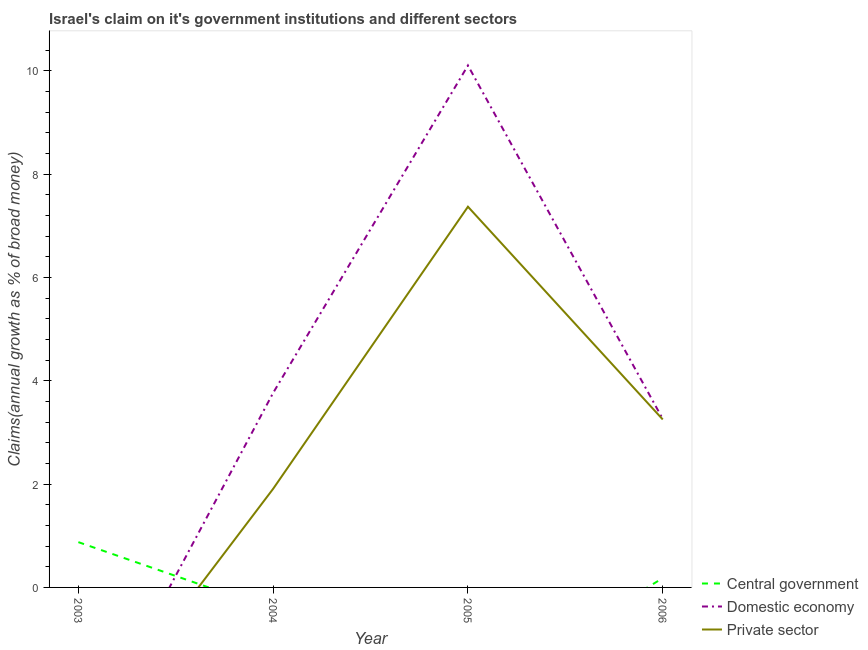How many different coloured lines are there?
Give a very brief answer. 3. What is the percentage of claim on the domestic economy in 2006?
Provide a succinct answer. 3.26. Across all years, what is the maximum percentage of claim on the private sector?
Offer a terse response. 7.37. In which year was the percentage of claim on the domestic economy maximum?
Offer a very short reply. 2005. What is the total percentage of claim on the central government in the graph?
Provide a short and direct response. 1.06. What is the difference between the percentage of claim on the domestic economy in 2004 and that in 2006?
Make the answer very short. 0.51. What is the difference between the percentage of claim on the private sector in 2006 and the percentage of claim on the domestic economy in 2005?
Your answer should be compact. -6.85. What is the average percentage of claim on the private sector per year?
Make the answer very short. 3.13. In the year 2006, what is the difference between the percentage of claim on the central government and percentage of claim on the private sector?
Make the answer very short. -3.07. In how many years, is the percentage of claim on the central government greater than 4.8 %?
Provide a succinct answer. 0. What is the ratio of the percentage of claim on the central government in 2003 to that in 2006?
Your answer should be compact. 4.87. Is the percentage of claim on the central government in 2003 less than that in 2006?
Offer a terse response. No. What is the difference between the highest and the second highest percentage of claim on the domestic economy?
Your answer should be compact. 6.34. What is the difference between the highest and the lowest percentage of claim on the domestic economy?
Give a very brief answer. 10.1. In how many years, is the percentage of claim on the private sector greater than the average percentage of claim on the private sector taken over all years?
Your answer should be compact. 2. Is the sum of the percentage of claim on the private sector in 2004 and 2005 greater than the maximum percentage of claim on the domestic economy across all years?
Provide a short and direct response. No. Is it the case that in every year, the sum of the percentage of claim on the central government and percentage of claim on the domestic economy is greater than the percentage of claim on the private sector?
Make the answer very short. Yes. Is the percentage of claim on the central government strictly greater than the percentage of claim on the private sector over the years?
Your response must be concise. No. How many years are there in the graph?
Provide a short and direct response. 4. What is the difference between two consecutive major ticks on the Y-axis?
Keep it short and to the point. 2. Are the values on the major ticks of Y-axis written in scientific E-notation?
Give a very brief answer. No. Does the graph contain any zero values?
Provide a succinct answer. Yes. Does the graph contain grids?
Your response must be concise. No. How are the legend labels stacked?
Offer a very short reply. Vertical. What is the title of the graph?
Your answer should be compact. Israel's claim on it's government institutions and different sectors. What is the label or title of the Y-axis?
Keep it short and to the point. Claims(annual growth as % of broad money). What is the Claims(annual growth as % of broad money) of Central government in 2003?
Make the answer very short. 0.88. What is the Claims(annual growth as % of broad money) in Private sector in 2003?
Your answer should be compact. 0. What is the Claims(annual growth as % of broad money) of Domestic economy in 2004?
Offer a very short reply. 3.77. What is the Claims(annual growth as % of broad money) in Private sector in 2004?
Provide a succinct answer. 1.91. What is the Claims(annual growth as % of broad money) of Central government in 2005?
Provide a short and direct response. 0. What is the Claims(annual growth as % of broad money) of Domestic economy in 2005?
Your answer should be very brief. 10.1. What is the Claims(annual growth as % of broad money) in Private sector in 2005?
Ensure brevity in your answer.  7.37. What is the Claims(annual growth as % of broad money) of Central government in 2006?
Provide a short and direct response. 0.18. What is the Claims(annual growth as % of broad money) of Domestic economy in 2006?
Make the answer very short. 3.26. What is the Claims(annual growth as % of broad money) in Private sector in 2006?
Give a very brief answer. 3.25. Across all years, what is the maximum Claims(annual growth as % of broad money) in Central government?
Your answer should be very brief. 0.88. Across all years, what is the maximum Claims(annual growth as % of broad money) of Domestic economy?
Ensure brevity in your answer.  10.1. Across all years, what is the maximum Claims(annual growth as % of broad money) of Private sector?
Make the answer very short. 7.37. Across all years, what is the minimum Claims(annual growth as % of broad money) of Central government?
Ensure brevity in your answer.  0. Across all years, what is the minimum Claims(annual growth as % of broad money) of Domestic economy?
Offer a terse response. 0. What is the total Claims(annual growth as % of broad money) in Central government in the graph?
Provide a succinct answer. 1.06. What is the total Claims(annual growth as % of broad money) of Domestic economy in the graph?
Provide a short and direct response. 17.13. What is the total Claims(annual growth as % of broad money) of Private sector in the graph?
Offer a very short reply. 12.53. What is the difference between the Claims(annual growth as % of broad money) in Central government in 2003 and that in 2006?
Your answer should be very brief. 0.7. What is the difference between the Claims(annual growth as % of broad money) in Domestic economy in 2004 and that in 2005?
Provide a succinct answer. -6.34. What is the difference between the Claims(annual growth as % of broad money) of Private sector in 2004 and that in 2005?
Provide a short and direct response. -5.46. What is the difference between the Claims(annual growth as % of broad money) of Domestic economy in 2004 and that in 2006?
Offer a terse response. 0.51. What is the difference between the Claims(annual growth as % of broad money) of Private sector in 2004 and that in 2006?
Provide a succinct answer. -1.34. What is the difference between the Claims(annual growth as % of broad money) of Domestic economy in 2005 and that in 2006?
Make the answer very short. 6.84. What is the difference between the Claims(annual growth as % of broad money) in Private sector in 2005 and that in 2006?
Make the answer very short. 4.12. What is the difference between the Claims(annual growth as % of broad money) of Central government in 2003 and the Claims(annual growth as % of broad money) of Domestic economy in 2004?
Your response must be concise. -2.89. What is the difference between the Claims(annual growth as % of broad money) in Central government in 2003 and the Claims(annual growth as % of broad money) in Private sector in 2004?
Your answer should be compact. -1.03. What is the difference between the Claims(annual growth as % of broad money) in Central government in 2003 and the Claims(annual growth as % of broad money) in Domestic economy in 2005?
Offer a terse response. -9.23. What is the difference between the Claims(annual growth as % of broad money) in Central government in 2003 and the Claims(annual growth as % of broad money) in Private sector in 2005?
Give a very brief answer. -6.49. What is the difference between the Claims(annual growth as % of broad money) in Central government in 2003 and the Claims(annual growth as % of broad money) in Domestic economy in 2006?
Your response must be concise. -2.38. What is the difference between the Claims(annual growth as % of broad money) in Central government in 2003 and the Claims(annual growth as % of broad money) in Private sector in 2006?
Your response must be concise. -2.37. What is the difference between the Claims(annual growth as % of broad money) of Domestic economy in 2004 and the Claims(annual growth as % of broad money) of Private sector in 2005?
Your answer should be very brief. -3.6. What is the difference between the Claims(annual growth as % of broad money) in Domestic economy in 2004 and the Claims(annual growth as % of broad money) in Private sector in 2006?
Provide a succinct answer. 0.51. What is the difference between the Claims(annual growth as % of broad money) in Domestic economy in 2005 and the Claims(annual growth as % of broad money) in Private sector in 2006?
Make the answer very short. 6.85. What is the average Claims(annual growth as % of broad money) of Central government per year?
Offer a terse response. 0.26. What is the average Claims(annual growth as % of broad money) in Domestic economy per year?
Provide a succinct answer. 4.28. What is the average Claims(annual growth as % of broad money) of Private sector per year?
Your response must be concise. 3.13. In the year 2004, what is the difference between the Claims(annual growth as % of broad money) of Domestic economy and Claims(annual growth as % of broad money) of Private sector?
Your answer should be compact. 1.86. In the year 2005, what is the difference between the Claims(annual growth as % of broad money) of Domestic economy and Claims(annual growth as % of broad money) of Private sector?
Ensure brevity in your answer.  2.73. In the year 2006, what is the difference between the Claims(annual growth as % of broad money) of Central government and Claims(annual growth as % of broad money) of Domestic economy?
Ensure brevity in your answer.  -3.08. In the year 2006, what is the difference between the Claims(annual growth as % of broad money) of Central government and Claims(annual growth as % of broad money) of Private sector?
Your response must be concise. -3.07. In the year 2006, what is the difference between the Claims(annual growth as % of broad money) of Domestic economy and Claims(annual growth as % of broad money) of Private sector?
Your response must be concise. 0.01. What is the ratio of the Claims(annual growth as % of broad money) of Central government in 2003 to that in 2006?
Give a very brief answer. 4.87. What is the ratio of the Claims(annual growth as % of broad money) in Domestic economy in 2004 to that in 2005?
Your answer should be very brief. 0.37. What is the ratio of the Claims(annual growth as % of broad money) of Private sector in 2004 to that in 2005?
Make the answer very short. 0.26. What is the ratio of the Claims(annual growth as % of broad money) of Domestic economy in 2004 to that in 2006?
Keep it short and to the point. 1.15. What is the ratio of the Claims(annual growth as % of broad money) of Private sector in 2004 to that in 2006?
Your answer should be compact. 0.59. What is the ratio of the Claims(annual growth as % of broad money) of Domestic economy in 2005 to that in 2006?
Keep it short and to the point. 3.1. What is the ratio of the Claims(annual growth as % of broad money) of Private sector in 2005 to that in 2006?
Ensure brevity in your answer.  2.27. What is the difference between the highest and the second highest Claims(annual growth as % of broad money) of Domestic economy?
Your answer should be compact. 6.34. What is the difference between the highest and the second highest Claims(annual growth as % of broad money) in Private sector?
Offer a terse response. 4.12. What is the difference between the highest and the lowest Claims(annual growth as % of broad money) of Central government?
Your answer should be very brief. 0.88. What is the difference between the highest and the lowest Claims(annual growth as % of broad money) of Domestic economy?
Give a very brief answer. 10.1. What is the difference between the highest and the lowest Claims(annual growth as % of broad money) of Private sector?
Ensure brevity in your answer.  7.37. 